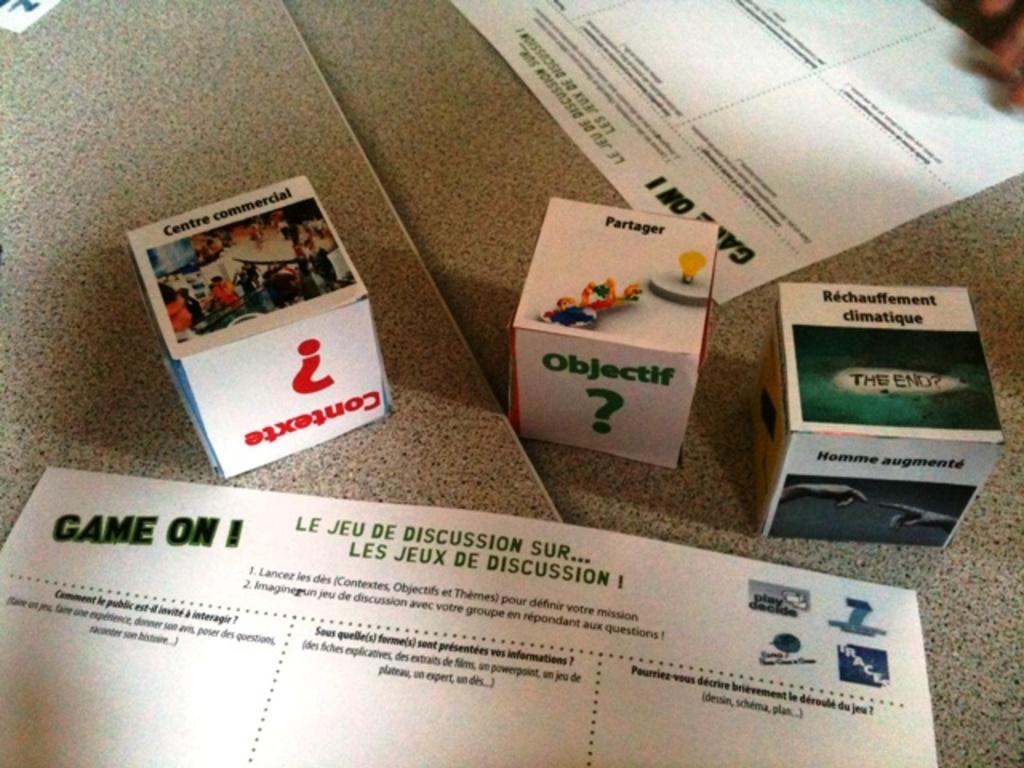<image>
Share a concise interpretation of the image provided. some cardboard squares and a sheet with 'Game On' written on it. 